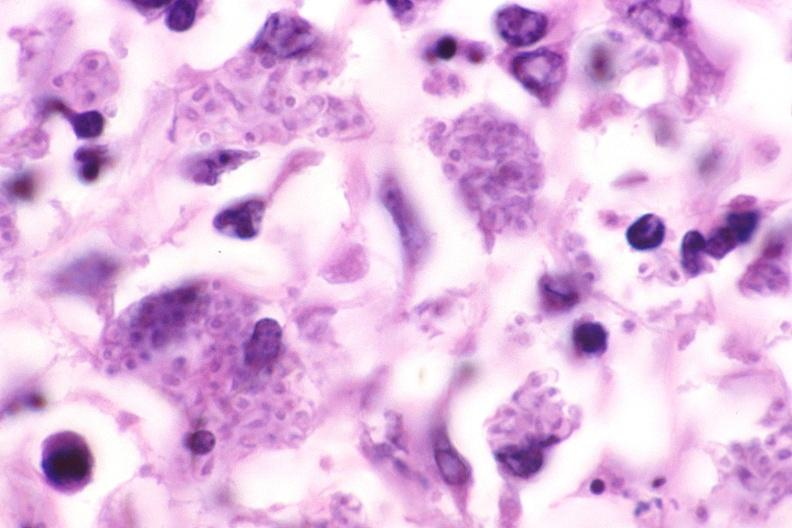s respiratory present?
Answer the question using a single word or phrase. Yes 